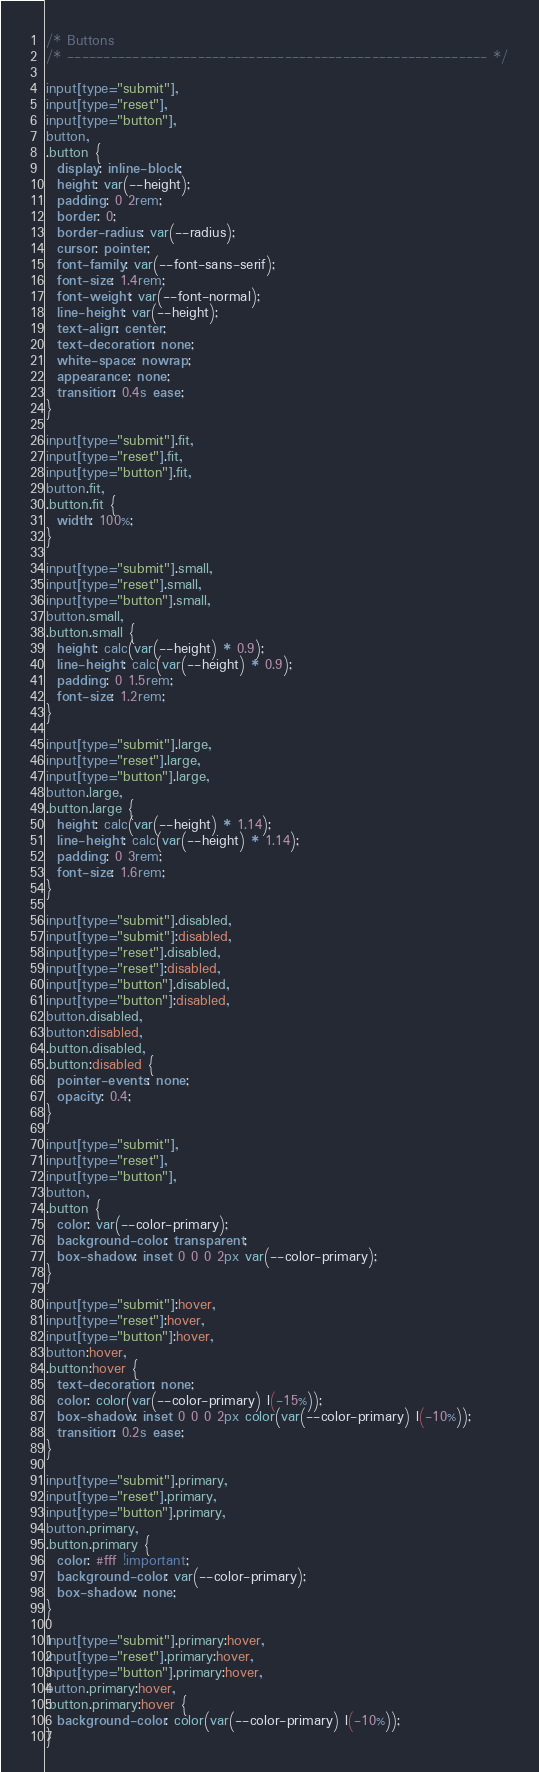Convert code to text. <code><loc_0><loc_0><loc_500><loc_500><_CSS_>/* Buttons
/* ---------------------------------------------------------- */

input[type="submit"],
input[type="reset"],
input[type="button"],
button,
.button {
  display: inline-block;
  height: var(--height);
  padding: 0 2rem;
  border: 0;
  border-radius: var(--radius);
  cursor: pointer;
  font-family: var(--font-sans-serif);
  font-size: 1.4rem;
  font-weight: var(--font-normal);
  line-height: var(--height);
  text-align: center;
  text-decoration: none;
  white-space: nowrap;
  appearance: none;
  transition: 0.4s ease;
}

input[type="submit"].fit,
input[type="reset"].fit,
input[type="button"].fit,
button.fit,
.button.fit {
  width: 100%;
}

input[type="submit"].small,
input[type="reset"].small,
input[type="button"].small,
button.small,
.button.small {
  height: calc(var(--height) * 0.9);
  line-height: calc(var(--height) * 0.9);
  padding: 0 1.5rem;
  font-size: 1.2rem;
}

input[type="submit"].large,
input[type="reset"].large,
input[type="button"].large,
button.large,
.button.large {
  height: calc(var(--height) * 1.14);
  line-height: calc(var(--height) * 1.14);
  padding: 0 3rem;
  font-size: 1.6rem;
}

input[type="submit"].disabled,
input[type="submit"]:disabled,
input[type="reset"].disabled,
input[type="reset"]:disabled,
input[type="button"].disabled,
input[type="button"]:disabled,
button.disabled,
button:disabled,
.button.disabled,
.button:disabled {
  pointer-events: none;
  opacity: 0.4;
}

input[type="submit"],
input[type="reset"],
input[type="button"],
button,
.button {
  color: var(--color-primary);
  background-color: transparent;
  box-shadow: inset 0 0 0 2px var(--color-primary);
}

input[type="submit"]:hover,
input[type="reset"]:hover,
input[type="button"]:hover,
button:hover,
.button:hover {
  text-decoration: none;
  color: color(var(--color-primary) l(-15%));
  box-shadow: inset 0 0 0 2px color(var(--color-primary) l(-10%));
  transition: 0.2s ease;
}

input[type="submit"].primary,
input[type="reset"].primary,
input[type="button"].primary,
button.primary,
.button.primary {
  color: #fff !important;
  background-color: var(--color-primary);
  box-shadow: none;
}

input[type="submit"].primary:hover,
input[type="reset"].primary:hover,
input[type="button"].primary:hover,
button.primary:hover,
.button.primary:hover {
  background-color: color(var(--color-primary) l(-10%));
}
</code> 